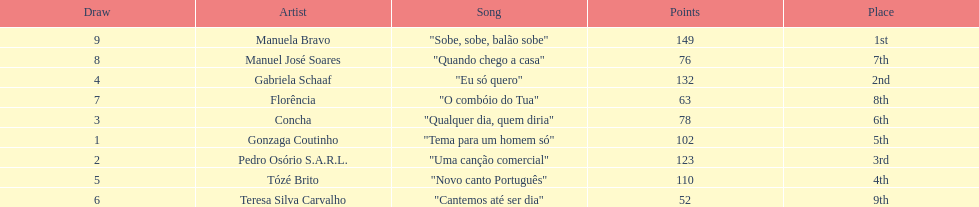Which artist came in last place? Teresa Silva Carvalho. 